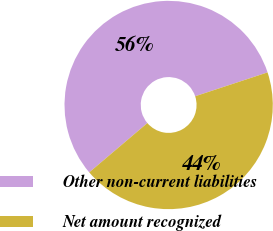<chart> <loc_0><loc_0><loc_500><loc_500><pie_chart><fcel>Other non-current liabilities<fcel>Net amount recognized<nl><fcel>56.13%<fcel>43.87%<nl></chart> 